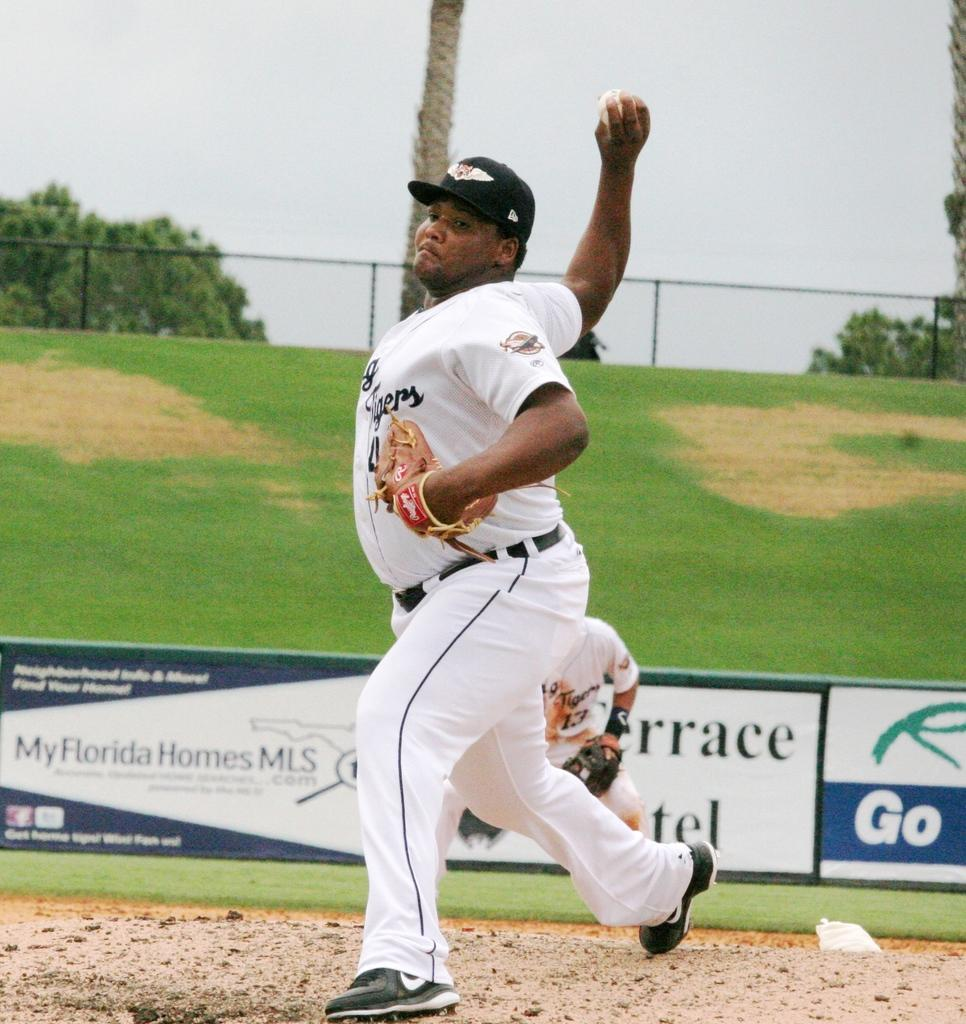Provide a one-sentence caption for the provided image. A man in a baseball uniform is about to pitch while at a filed with a advertisement that says My Florida Homes MLS. 